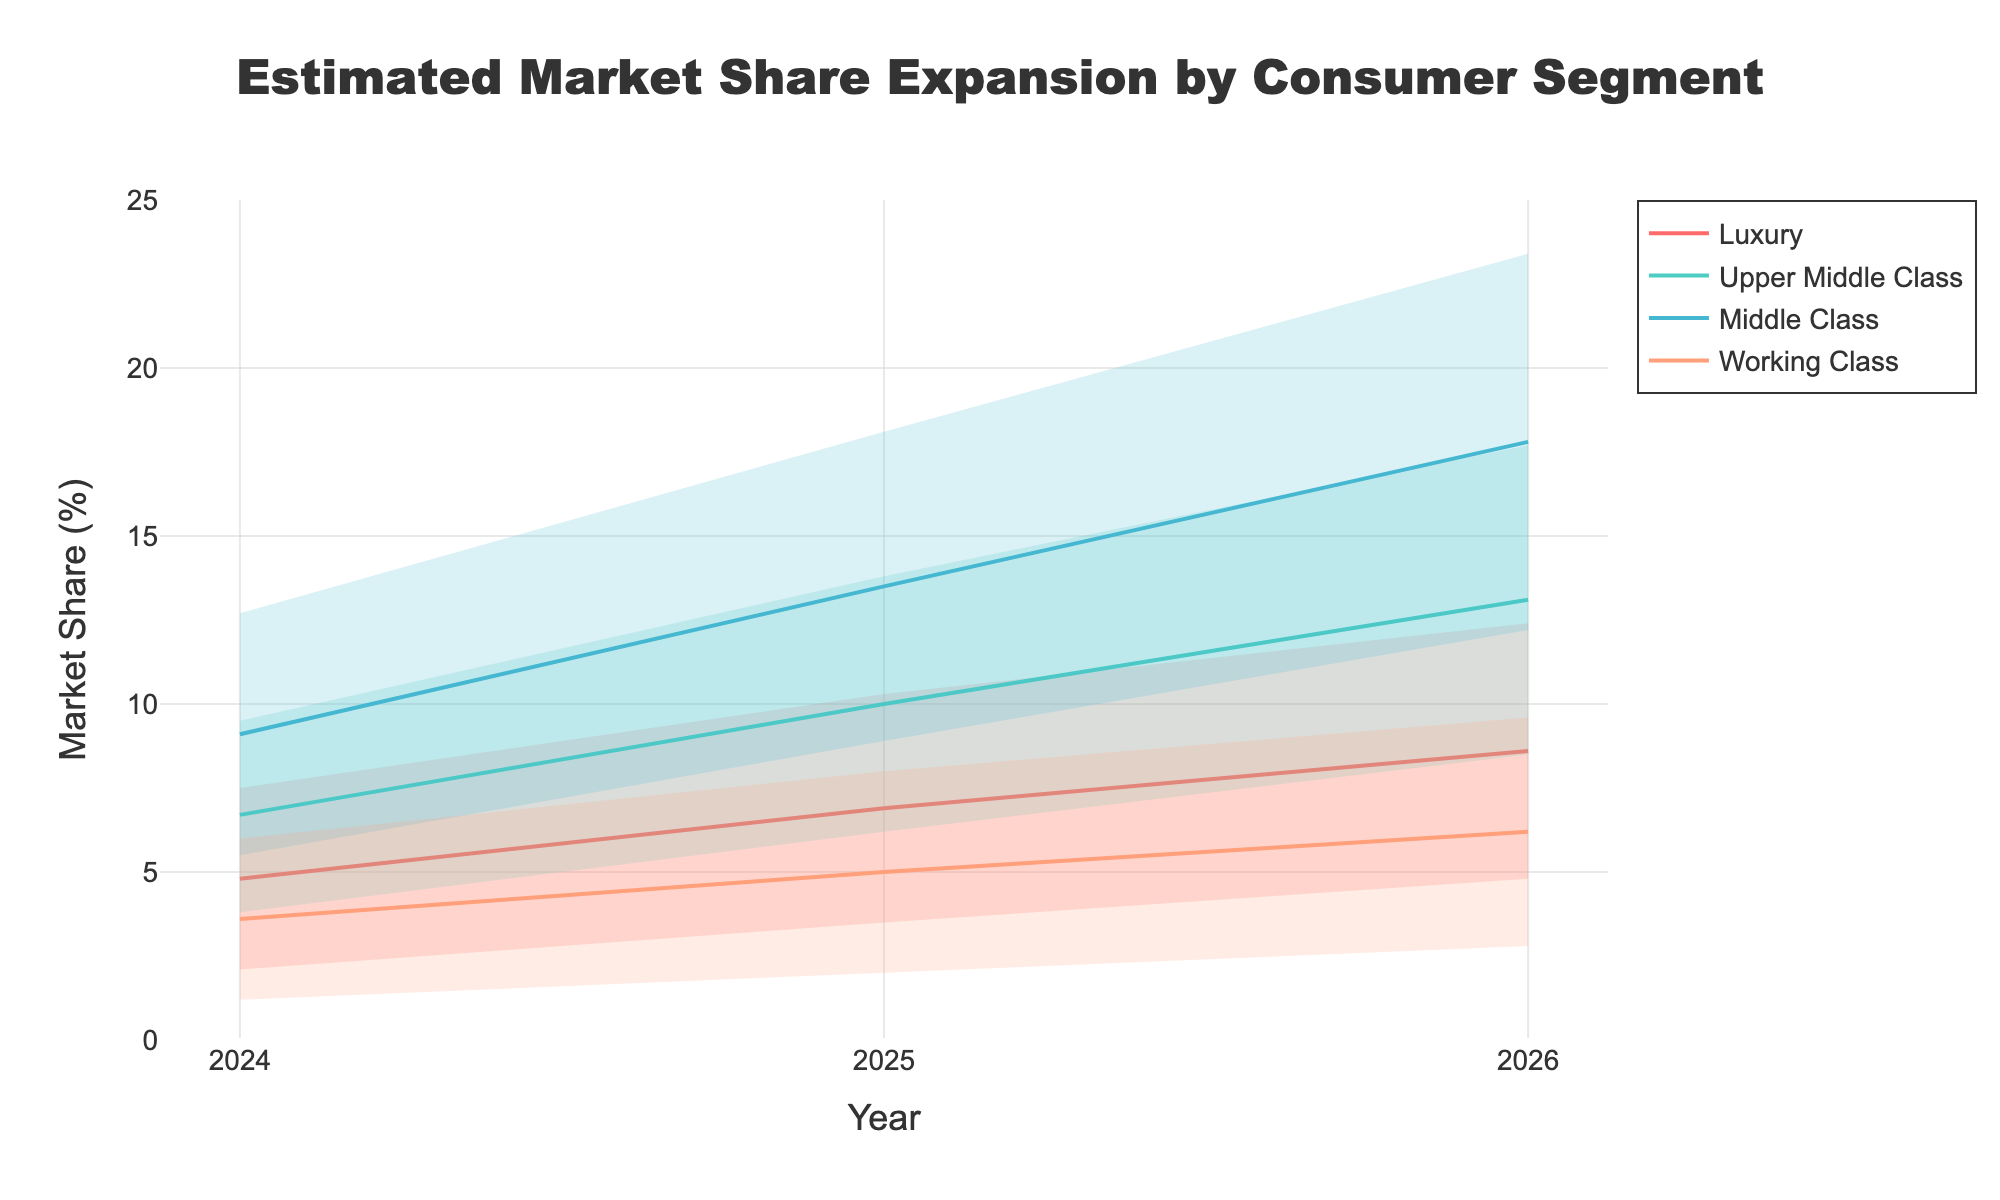what's the title of the chart? The title of the chart is displayed at the top of the figure. It reads 'Estimated Market Share Expansion by Consumer Segment'.
Answer: Estimated Market Share Expansion by Consumer Segment What are the years represented in this chart? The x-axis of the chart lists the years. The years represented are 2024, 2025, and 2026.
Answer: 2024, 2025, 2026 Which consumer segment shows the highest median market share in 2026? To determine this, look at the median lines and identify the one with the highest value in 2026. The 'Middle Class' segment shows the highest median market share in 2026 at 17.8%.
Answer: Middle Class What is the range between the low and high estimates for the Upper Middle Class segment in 2025? Subtract the low estimate from the high estimate for the Upper Middle Class segment in 2025. The values are 6.2% (low) and 13.8% (high). The range is 13.8 - 6.2.
Answer: 7.6% How does the median market share of the Luxury segment change from 2024 to 2025? The median market share for the Luxury segment in 2024 is 4.8%, and in 2025 it is 6.9%. The difference is 6.9 - 4.8. The median market share increases by 2.1%.
Answer: Increases by 2.1% Which consumer segment exhibits the smallest upper bound estimate in 2024? Compare the upper bound estimates for all segments in 2024. The Working Class segment has the smallest upper bound at 6.0%.
Answer: Working Class What is the middle point of the market share range for the Working Class segment in 2024? The middle point can be found by taking the average of the low and high estimates for the Working Class segment in 2024. The values are 1.2% (low) and 6.0% (high). The middle point is (1.2 + 6.0) / 2.
Answer: 3.6% Which year shows the greatest forecasted growth for the Middle Class segment according to the median estimates? Calculate the difference in the median estimates of the Middle Class from year to year. From 2024 to 2025, the median grows by 4.4% (9.1 - 4.7). From 2025 to 2026, it grows by 4.3% (17.8 - 13.5). The year with the greatest growth is from 2024 to 2025.
Answer: 2024 to 2025 Comparing the Upper Middle Class and Working Class segments in 2025, which one has a higher lower bound estimate? The lower bound estimate for the Upper Middle Class in 2025 is 6.2%, and for the Working Class, it is 2.0%. The Upper Middle Class has a higher lower bound estimate.
Answer: Upper Middle Class 